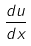<formula> <loc_0><loc_0><loc_500><loc_500>\frac { d u } { d x }</formula> 